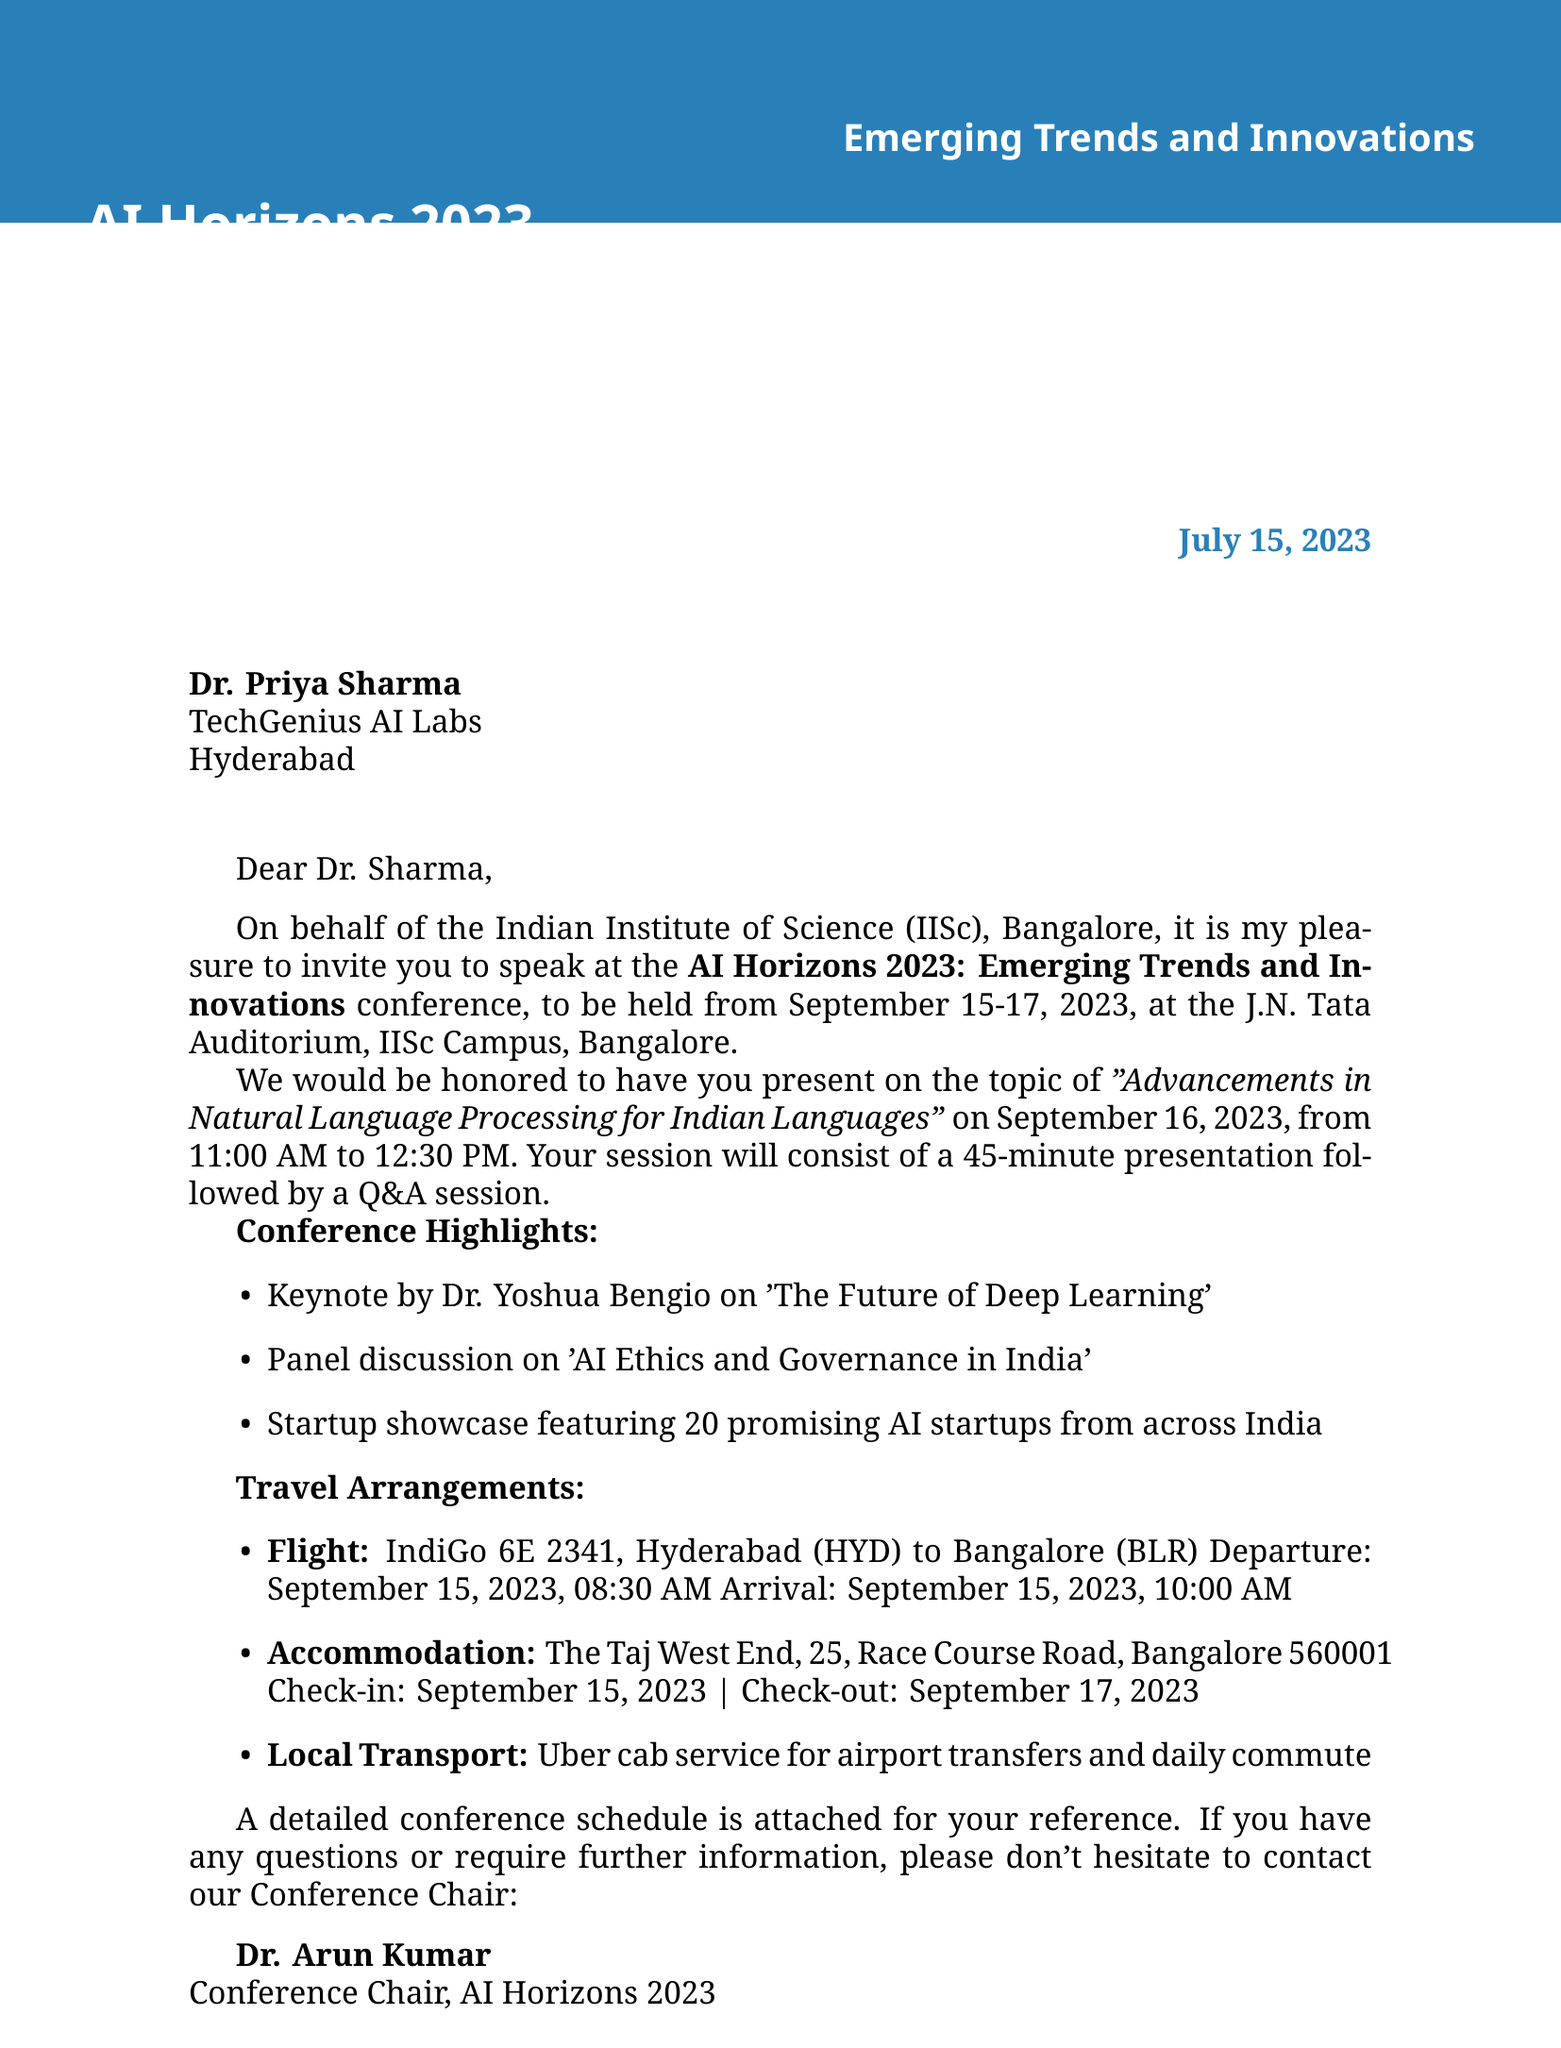What is the name of the conference? The conference is formally titled "AI Horizons 2023: Emerging Trends and Innovations" as stated at the beginning of the document.
Answer: AI Horizons 2023: Emerging Trends and Innovations Who is the organizer of the event? The document mentions that the conference is organized by the "Indian Institute of Science (IISc), Bangalore."
Answer: Indian Institute of Science (IISc), Bangalore What is the date of Dr. Priya Sharma's presentation? The date of her presentation is specified in the invitation details section of the document.
Answer: September 16, 2023 What is the session format for Dr. Sharma's presentation? The format includes a 45-minute presentation followed by a Q&A, as detailed in the invitation letters.
Answer: 45-minute presentation followed by Q&A Which hotel will Dr. Priya Sharma be staying at? The accommodation details include the name of the hotel where she will lodge during the conference.
Answer: The Taj West End What time does the keynote by Dr. Yoshua Bengio start? The schedule provides the starting time for this keynote event on September 15, 2023.
Answer: 12:00 PM How long is the conference? The duration of the conference is specified at the top of the invitation letter.
Answer: Three days Who should be contacted for further information? The document lists a specific contact person for inquiries related to the conference.
Answer: Dr. Arun Kumar What is the transport arrangement mentioned in the document? It indicates that Uber cab service will be provided for transportation needs during the event.
Answer: Uber cab service 